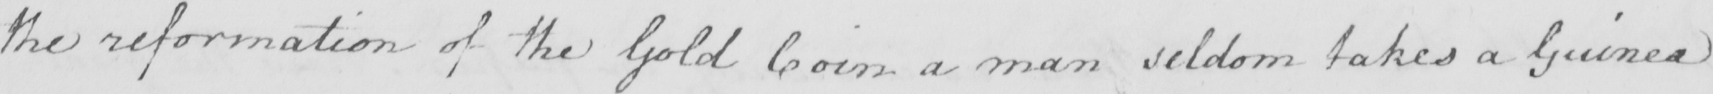Please provide the text content of this handwritten line. the reformation of the Gold Coin a man seldom takes a Guinea 